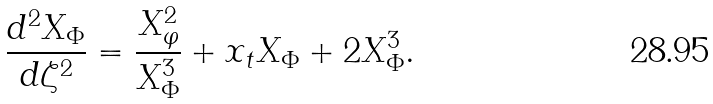Convert formula to latex. <formula><loc_0><loc_0><loc_500><loc_500>\frac { d ^ { 2 } X _ { \Phi } } { d \zeta ^ { 2 } } = \frac { X ^ { 2 } _ { \varphi } } { X _ { \Phi } ^ { 3 } } + x _ { t } X _ { \Phi } + 2 X _ { \Phi } ^ { 3 } .</formula> 